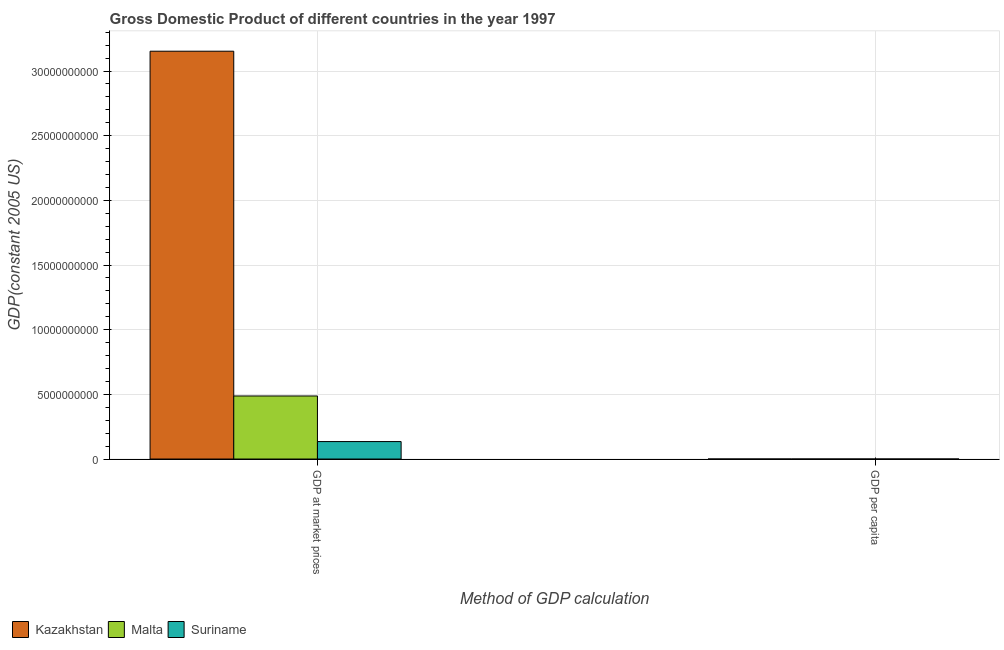Are the number of bars per tick equal to the number of legend labels?
Provide a succinct answer. Yes. How many bars are there on the 1st tick from the left?
Provide a short and direct response. 3. How many bars are there on the 1st tick from the right?
Keep it short and to the point. 3. What is the label of the 1st group of bars from the left?
Make the answer very short. GDP at market prices. What is the gdp at market prices in Malta?
Your answer should be compact. 4.88e+09. Across all countries, what is the maximum gdp at market prices?
Ensure brevity in your answer.  3.15e+1. Across all countries, what is the minimum gdp per capita?
Provide a succinct answer. 2056.32. In which country was the gdp per capita maximum?
Provide a succinct answer. Malta. In which country was the gdp per capita minimum?
Provide a short and direct response. Kazakhstan. What is the total gdp per capita in the graph?
Your answer should be very brief. 1.80e+04. What is the difference between the gdp per capita in Kazakhstan and that in Suriname?
Keep it short and to the point. -868.27. What is the difference between the gdp at market prices in Suriname and the gdp per capita in Kazakhstan?
Keep it short and to the point. 1.35e+09. What is the average gdp at market prices per country?
Ensure brevity in your answer.  1.26e+1. What is the difference between the gdp at market prices and gdp per capita in Suriname?
Keep it short and to the point. 1.35e+09. In how many countries, is the gdp per capita greater than 3000000000 US$?
Your response must be concise. 0. What is the ratio of the gdp per capita in Malta to that in Suriname?
Offer a terse response. 4.44. Is the gdp at market prices in Malta less than that in Kazakhstan?
Your answer should be very brief. Yes. What does the 2nd bar from the left in GDP per capita represents?
Your response must be concise. Malta. What does the 2nd bar from the right in GDP per capita represents?
Ensure brevity in your answer.  Malta. How many bars are there?
Give a very brief answer. 6. Are all the bars in the graph horizontal?
Make the answer very short. No. What is the difference between two consecutive major ticks on the Y-axis?
Provide a short and direct response. 5.00e+09. Does the graph contain any zero values?
Make the answer very short. No. How are the legend labels stacked?
Your answer should be very brief. Horizontal. What is the title of the graph?
Provide a short and direct response. Gross Domestic Product of different countries in the year 1997. Does "Small states" appear as one of the legend labels in the graph?
Your answer should be very brief. No. What is the label or title of the X-axis?
Offer a very short reply. Method of GDP calculation. What is the label or title of the Y-axis?
Your answer should be very brief. GDP(constant 2005 US). What is the GDP(constant 2005 US) of Kazakhstan in GDP at market prices?
Your answer should be very brief. 3.15e+1. What is the GDP(constant 2005 US) in Malta in GDP at market prices?
Provide a short and direct response. 4.88e+09. What is the GDP(constant 2005 US) in Suriname in GDP at market prices?
Your response must be concise. 1.35e+09. What is the GDP(constant 2005 US) in Kazakhstan in GDP per capita?
Your response must be concise. 2056.32. What is the GDP(constant 2005 US) of Malta in GDP per capita?
Ensure brevity in your answer.  1.30e+04. What is the GDP(constant 2005 US) of Suriname in GDP per capita?
Keep it short and to the point. 2924.59. Across all Method of GDP calculation, what is the maximum GDP(constant 2005 US) in Kazakhstan?
Keep it short and to the point. 3.15e+1. Across all Method of GDP calculation, what is the maximum GDP(constant 2005 US) in Malta?
Offer a terse response. 4.88e+09. Across all Method of GDP calculation, what is the maximum GDP(constant 2005 US) in Suriname?
Your answer should be very brief. 1.35e+09. Across all Method of GDP calculation, what is the minimum GDP(constant 2005 US) in Kazakhstan?
Give a very brief answer. 2056.32. Across all Method of GDP calculation, what is the minimum GDP(constant 2005 US) of Malta?
Offer a terse response. 1.30e+04. Across all Method of GDP calculation, what is the minimum GDP(constant 2005 US) of Suriname?
Provide a succinct answer. 2924.59. What is the total GDP(constant 2005 US) in Kazakhstan in the graph?
Ensure brevity in your answer.  3.15e+1. What is the total GDP(constant 2005 US) of Malta in the graph?
Provide a short and direct response. 4.88e+09. What is the total GDP(constant 2005 US) of Suriname in the graph?
Provide a succinct answer. 1.35e+09. What is the difference between the GDP(constant 2005 US) in Kazakhstan in GDP at market prices and that in GDP per capita?
Provide a succinct answer. 3.15e+1. What is the difference between the GDP(constant 2005 US) in Malta in GDP at market prices and that in GDP per capita?
Your response must be concise. 4.88e+09. What is the difference between the GDP(constant 2005 US) in Suriname in GDP at market prices and that in GDP per capita?
Make the answer very short. 1.35e+09. What is the difference between the GDP(constant 2005 US) of Kazakhstan in GDP at market prices and the GDP(constant 2005 US) of Malta in GDP per capita?
Offer a terse response. 3.15e+1. What is the difference between the GDP(constant 2005 US) in Kazakhstan in GDP at market prices and the GDP(constant 2005 US) in Suriname in GDP per capita?
Ensure brevity in your answer.  3.15e+1. What is the difference between the GDP(constant 2005 US) in Malta in GDP at market prices and the GDP(constant 2005 US) in Suriname in GDP per capita?
Your answer should be compact. 4.88e+09. What is the average GDP(constant 2005 US) in Kazakhstan per Method of GDP calculation?
Provide a succinct answer. 1.58e+1. What is the average GDP(constant 2005 US) of Malta per Method of GDP calculation?
Give a very brief answer. 2.44e+09. What is the average GDP(constant 2005 US) of Suriname per Method of GDP calculation?
Your answer should be very brief. 6.75e+08. What is the difference between the GDP(constant 2005 US) in Kazakhstan and GDP(constant 2005 US) in Malta in GDP at market prices?
Your answer should be very brief. 2.67e+1. What is the difference between the GDP(constant 2005 US) of Kazakhstan and GDP(constant 2005 US) of Suriname in GDP at market prices?
Your answer should be very brief. 3.02e+1. What is the difference between the GDP(constant 2005 US) of Malta and GDP(constant 2005 US) of Suriname in GDP at market prices?
Make the answer very short. 3.53e+09. What is the difference between the GDP(constant 2005 US) in Kazakhstan and GDP(constant 2005 US) in Malta in GDP per capita?
Your response must be concise. -1.09e+04. What is the difference between the GDP(constant 2005 US) of Kazakhstan and GDP(constant 2005 US) of Suriname in GDP per capita?
Ensure brevity in your answer.  -868.27. What is the difference between the GDP(constant 2005 US) in Malta and GDP(constant 2005 US) in Suriname in GDP per capita?
Your answer should be compact. 1.01e+04. What is the ratio of the GDP(constant 2005 US) of Kazakhstan in GDP at market prices to that in GDP per capita?
Ensure brevity in your answer.  1.53e+07. What is the ratio of the GDP(constant 2005 US) in Malta in GDP at market prices to that in GDP per capita?
Your response must be concise. 3.75e+05. What is the ratio of the GDP(constant 2005 US) in Suriname in GDP at market prices to that in GDP per capita?
Your response must be concise. 4.62e+05. What is the difference between the highest and the second highest GDP(constant 2005 US) of Kazakhstan?
Give a very brief answer. 3.15e+1. What is the difference between the highest and the second highest GDP(constant 2005 US) of Malta?
Keep it short and to the point. 4.88e+09. What is the difference between the highest and the second highest GDP(constant 2005 US) in Suriname?
Your answer should be very brief. 1.35e+09. What is the difference between the highest and the lowest GDP(constant 2005 US) of Kazakhstan?
Provide a short and direct response. 3.15e+1. What is the difference between the highest and the lowest GDP(constant 2005 US) of Malta?
Give a very brief answer. 4.88e+09. What is the difference between the highest and the lowest GDP(constant 2005 US) in Suriname?
Keep it short and to the point. 1.35e+09. 